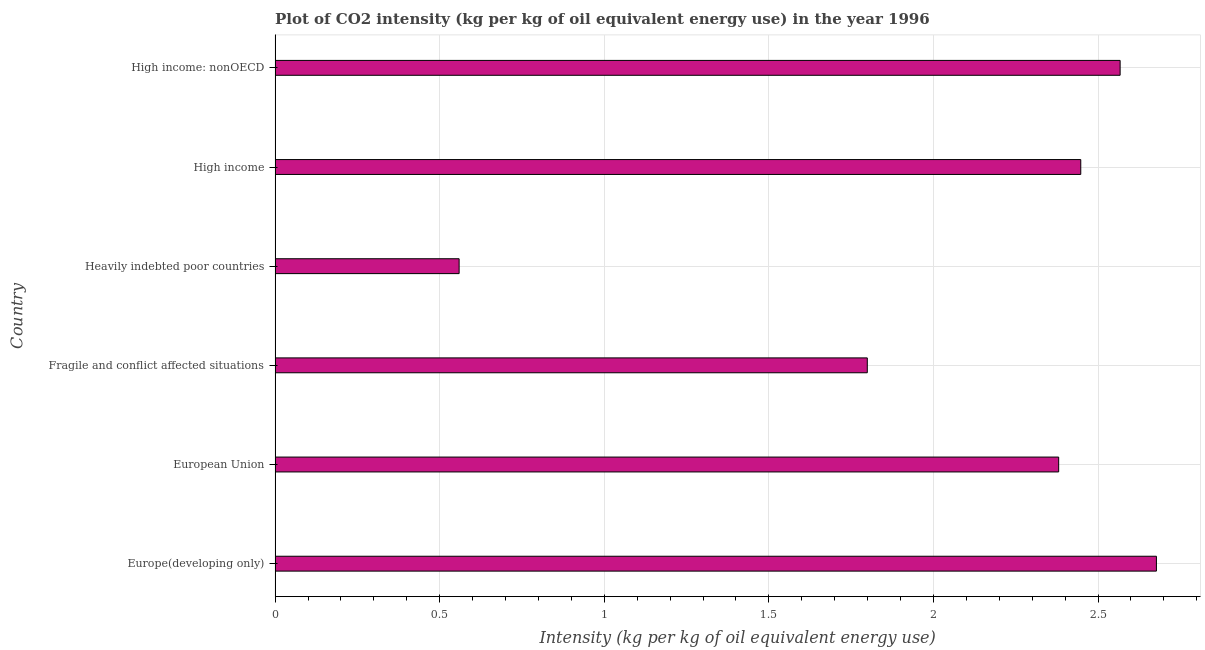Does the graph contain any zero values?
Ensure brevity in your answer.  No. Does the graph contain grids?
Provide a short and direct response. Yes. What is the title of the graph?
Your answer should be compact. Plot of CO2 intensity (kg per kg of oil equivalent energy use) in the year 1996. What is the label or title of the X-axis?
Keep it short and to the point. Intensity (kg per kg of oil equivalent energy use). What is the label or title of the Y-axis?
Make the answer very short. Country. What is the co2 intensity in High income: nonOECD?
Offer a terse response. 2.57. Across all countries, what is the maximum co2 intensity?
Offer a very short reply. 2.68. Across all countries, what is the minimum co2 intensity?
Ensure brevity in your answer.  0.56. In which country was the co2 intensity maximum?
Offer a terse response. Europe(developing only). In which country was the co2 intensity minimum?
Provide a short and direct response. Heavily indebted poor countries. What is the sum of the co2 intensity?
Provide a succinct answer. 12.43. What is the difference between the co2 intensity in Fragile and conflict affected situations and High income: nonOECD?
Your answer should be very brief. -0.77. What is the average co2 intensity per country?
Provide a short and direct response. 2.07. What is the median co2 intensity?
Make the answer very short. 2.41. In how many countries, is the co2 intensity greater than 1.5 kg?
Offer a terse response. 5. What is the ratio of the co2 intensity in European Union to that in Fragile and conflict affected situations?
Give a very brief answer. 1.32. Is the co2 intensity in European Union less than that in High income?
Your answer should be very brief. Yes. What is the difference between the highest and the second highest co2 intensity?
Give a very brief answer. 0.11. What is the difference between the highest and the lowest co2 intensity?
Your answer should be very brief. 2.12. Are the values on the major ticks of X-axis written in scientific E-notation?
Your answer should be very brief. No. What is the Intensity (kg per kg of oil equivalent energy use) of Europe(developing only)?
Offer a terse response. 2.68. What is the Intensity (kg per kg of oil equivalent energy use) of European Union?
Provide a short and direct response. 2.38. What is the Intensity (kg per kg of oil equivalent energy use) in Fragile and conflict affected situations?
Your response must be concise. 1.8. What is the Intensity (kg per kg of oil equivalent energy use) of Heavily indebted poor countries?
Offer a very short reply. 0.56. What is the Intensity (kg per kg of oil equivalent energy use) in High income?
Offer a terse response. 2.45. What is the Intensity (kg per kg of oil equivalent energy use) of High income: nonOECD?
Offer a very short reply. 2.57. What is the difference between the Intensity (kg per kg of oil equivalent energy use) in Europe(developing only) and European Union?
Make the answer very short. 0.3. What is the difference between the Intensity (kg per kg of oil equivalent energy use) in Europe(developing only) and Fragile and conflict affected situations?
Your answer should be compact. 0.88. What is the difference between the Intensity (kg per kg of oil equivalent energy use) in Europe(developing only) and Heavily indebted poor countries?
Provide a short and direct response. 2.12. What is the difference between the Intensity (kg per kg of oil equivalent energy use) in Europe(developing only) and High income?
Your response must be concise. 0.23. What is the difference between the Intensity (kg per kg of oil equivalent energy use) in Europe(developing only) and High income: nonOECD?
Your answer should be very brief. 0.11. What is the difference between the Intensity (kg per kg of oil equivalent energy use) in European Union and Fragile and conflict affected situations?
Keep it short and to the point. 0.58. What is the difference between the Intensity (kg per kg of oil equivalent energy use) in European Union and Heavily indebted poor countries?
Offer a very short reply. 1.82. What is the difference between the Intensity (kg per kg of oil equivalent energy use) in European Union and High income?
Your answer should be very brief. -0.07. What is the difference between the Intensity (kg per kg of oil equivalent energy use) in European Union and High income: nonOECD?
Your answer should be very brief. -0.19. What is the difference between the Intensity (kg per kg of oil equivalent energy use) in Fragile and conflict affected situations and Heavily indebted poor countries?
Provide a short and direct response. 1.24. What is the difference between the Intensity (kg per kg of oil equivalent energy use) in Fragile and conflict affected situations and High income?
Provide a short and direct response. -0.65. What is the difference between the Intensity (kg per kg of oil equivalent energy use) in Fragile and conflict affected situations and High income: nonOECD?
Make the answer very short. -0.77. What is the difference between the Intensity (kg per kg of oil equivalent energy use) in Heavily indebted poor countries and High income?
Ensure brevity in your answer.  -1.89. What is the difference between the Intensity (kg per kg of oil equivalent energy use) in Heavily indebted poor countries and High income: nonOECD?
Provide a succinct answer. -2.01. What is the difference between the Intensity (kg per kg of oil equivalent energy use) in High income and High income: nonOECD?
Keep it short and to the point. -0.12. What is the ratio of the Intensity (kg per kg of oil equivalent energy use) in Europe(developing only) to that in Fragile and conflict affected situations?
Offer a very short reply. 1.49. What is the ratio of the Intensity (kg per kg of oil equivalent energy use) in Europe(developing only) to that in Heavily indebted poor countries?
Make the answer very short. 4.79. What is the ratio of the Intensity (kg per kg of oil equivalent energy use) in Europe(developing only) to that in High income?
Offer a terse response. 1.09. What is the ratio of the Intensity (kg per kg of oil equivalent energy use) in Europe(developing only) to that in High income: nonOECD?
Keep it short and to the point. 1.04. What is the ratio of the Intensity (kg per kg of oil equivalent energy use) in European Union to that in Fragile and conflict affected situations?
Your response must be concise. 1.32. What is the ratio of the Intensity (kg per kg of oil equivalent energy use) in European Union to that in Heavily indebted poor countries?
Offer a terse response. 4.26. What is the ratio of the Intensity (kg per kg of oil equivalent energy use) in European Union to that in High income?
Your answer should be very brief. 0.97. What is the ratio of the Intensity (kg per kg of oil equivalent energy use) in European Union to that in High income: nonOECD?
Offer a terse response. 0.93. What is the ratio of the Intensity (kg per kg of oil equivalent energy use) in Fragile and conflict affected situations to that in Heavily indebted poor countries?
Make the answer very short. 3.22. What is the ratio of the Intensity (kg per kg of oil equivalent energy use) in Fragile and conflict affected situations to that in High income?
Your answer should be compact. 0.73. What is the ratio of the Intensity (kg per kg of oil equivalent energy use) in Fragile and conflict affected situations to that in High income: nonOECD?
Your answer should be very brief. 0.7. What is the ratio of the Intensity (kg per kg of oil equivalent energy use) in Heavily indebted poor countries to that in High income?
Your answer should be very brief. 0.23. What is the ratio of the Intensity (kg per kg of oil equivalent energy use) in Heavily indebted poor countries to that in High income: nonOECD?
Provide a short and direct response. 0.22. What is the ratio of the Intensity (kg per kg of oil equivalent energy use) in High income to that in High income: nonOECD?
Provide a succinct answer. 0.95. 